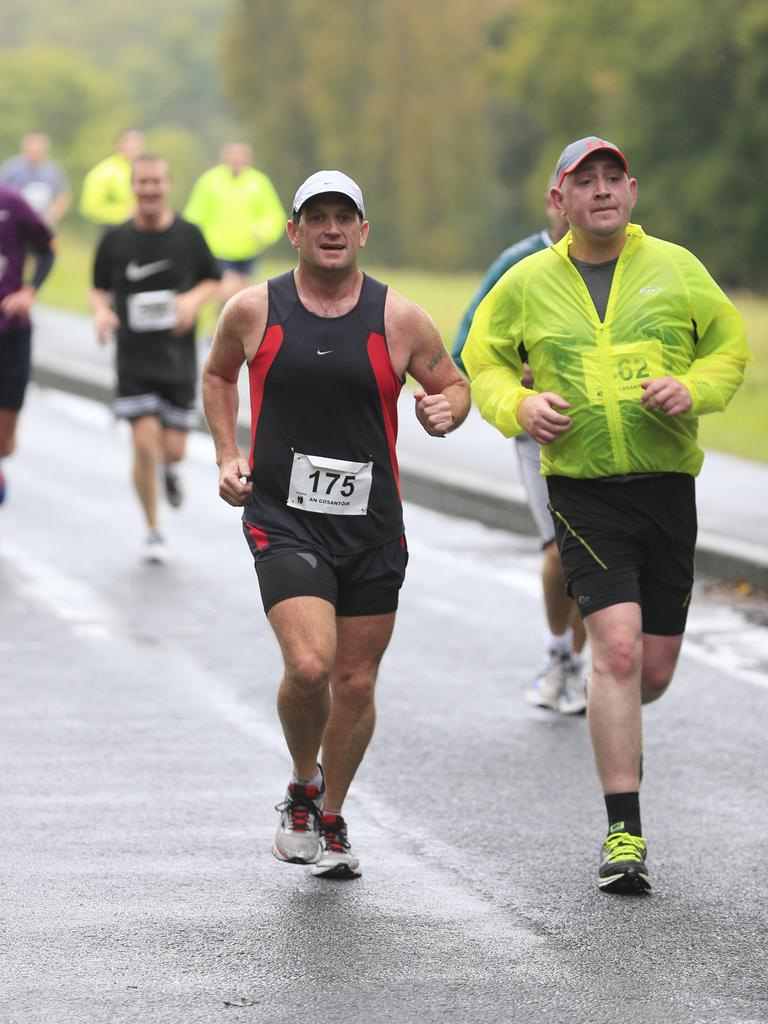What are the people in the image doing? The people in the image are running. Can you describe the clothing of the two persons in the front? The two persons in the front are wearing caps. What can be seen in the background of the image? There are trees and grass visible in the background of the image. Can you tell me how many marbles are scattered on the dock in the image? There are no marbles or docks present in the image; it features people running with trees and grass in the background. 